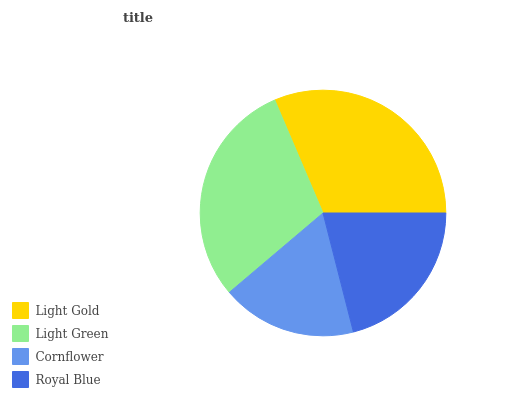Is Cornflower the minimum?
Answer yes or no. Yes. Is Light Gold the maximum?
Answer yes or no. Yes. Is Light Green the minimum?
Answer yes or no. No. Is Light Green the maximum?
Answer yes or no. No. Is Light Gold greater than Light Green?
Answer yes or no. Yes. Is Light Green less than Light Gold?
Answer yes or no. Yes. Is Light Green greater than Light Gold?
Answer yes or no. No. Is Light Gold less than Light Green?
Answer yes or no. No. Is Light Green the high median?
Answer yes or no. Yes. Is Royal Blue the low median?
Answer yes or no. Yes. Is Light Gold the high median?
Answer yes or no. No. Is Light Gold the low median?
Answer yes or no. No. 